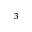Convert formula to latex. <formula><loc_0><loc_0><loc_500><loc_500>^ { 3 }</formula> 